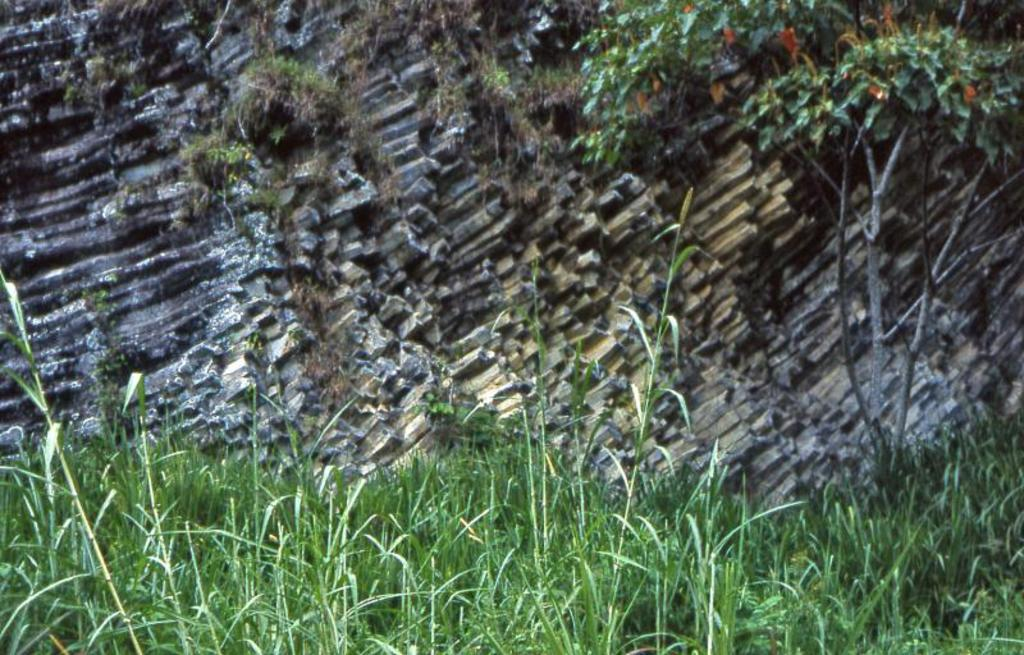What type of vegetation can be seen in the image? There are plants and trees in the image. Can you describe any other objects or features in the image? Yes, sticks are present in the image. What type of chess piece is depicted among the plants in the image? There is no chess piece present in the image; it features plants, trees, and sticks. Can you see a ghost hiding among the trees in the image? There is no ghost present in the image; it only contains plants, trees, and sticks. 